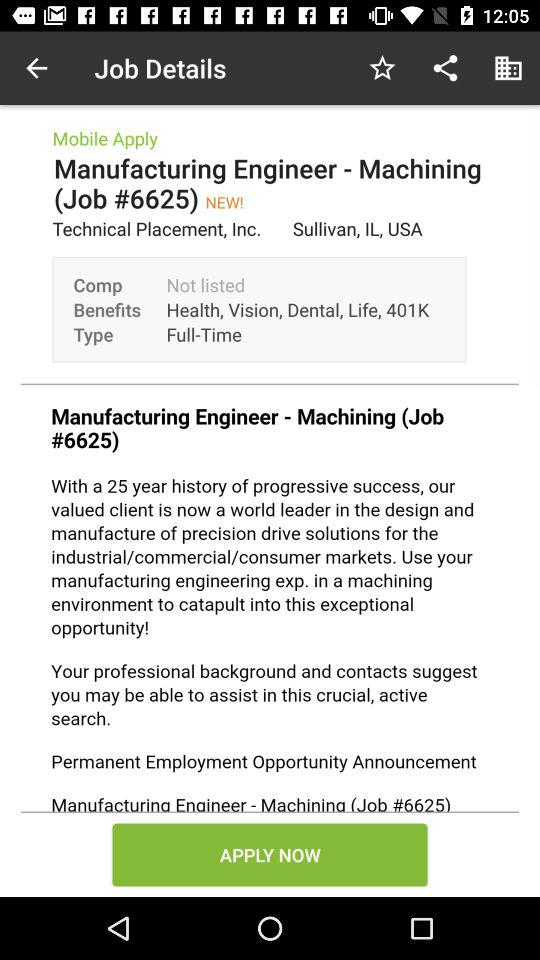What is the location of the job? The location of the job is Sullivan, IL, USA. 